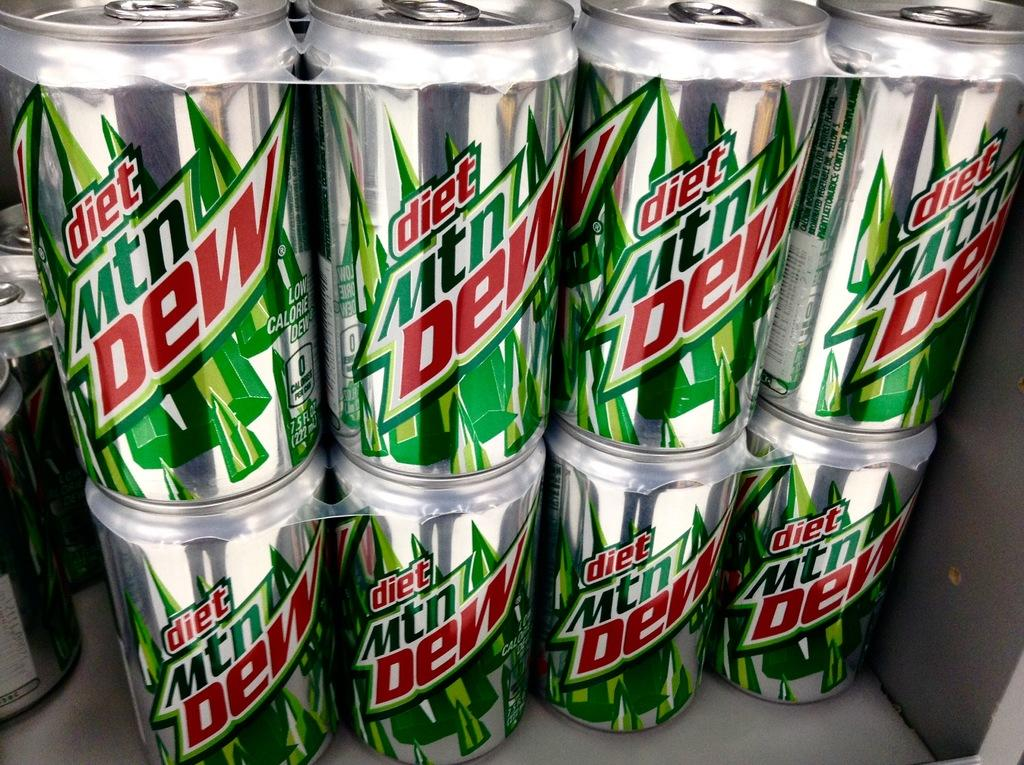What type of product is featured in the image? There are Mountain Dew tins in the image. What advice does the grandmother give about planting the seed in the image? There is no grandmother or seed present in the image; it only features Mountain Dew tins. 